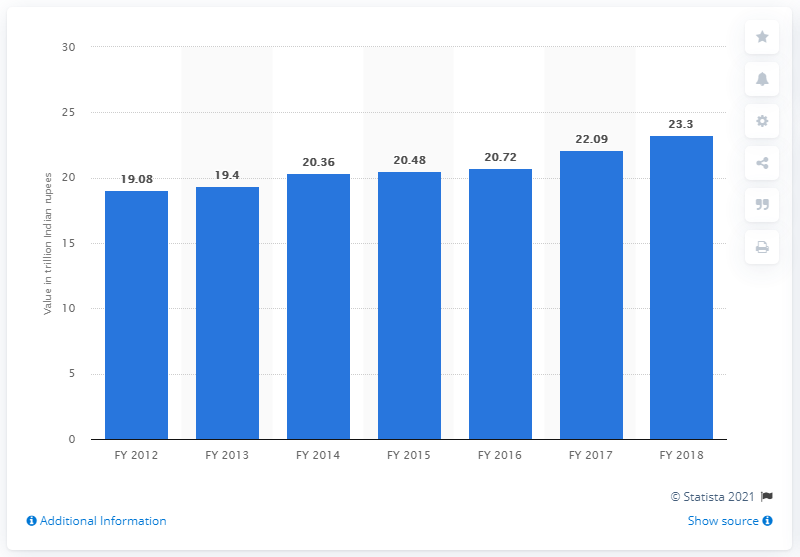Draw attention to some important aspects in this diagram. In the fiscal year 2018, the agriculture, forestry, and fishing sector contributed 23.3% to India's gross value output. 